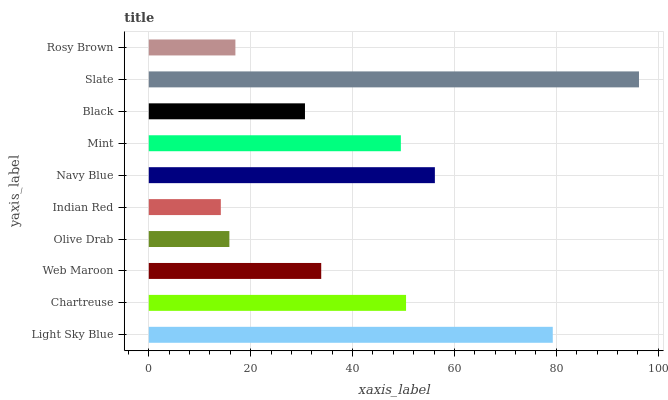Is Indian Red the minimum?
Answer yes or no. Yes. Is Slate the maximum?
Answer yes or no. Yes. Is Chartreuse the minimum?
Answer yes or no. No. Is Chartreuse the maximum?
Answer yes or no. No. Is Light Sky Blue greater than Chartreuse?
Answer yes or no. Yes. Is Chartreuse less than Light Sky Blue?
Answer yes or no. Yes. Is Chartreuse greater than Light Sky Blue?
Answer yes or no. No. Is Light Sky Blue less than Chartreuse?
Answer yes or no. No. Is Mint the high median?
Answer yes or no. Yes. Is Web Maroon the low median?
Answer yes or no. Yes. Is Web Maroon the high median?
Answer yes or no. No. Is Chartreuse the low median?
Answer yes or no. No. 